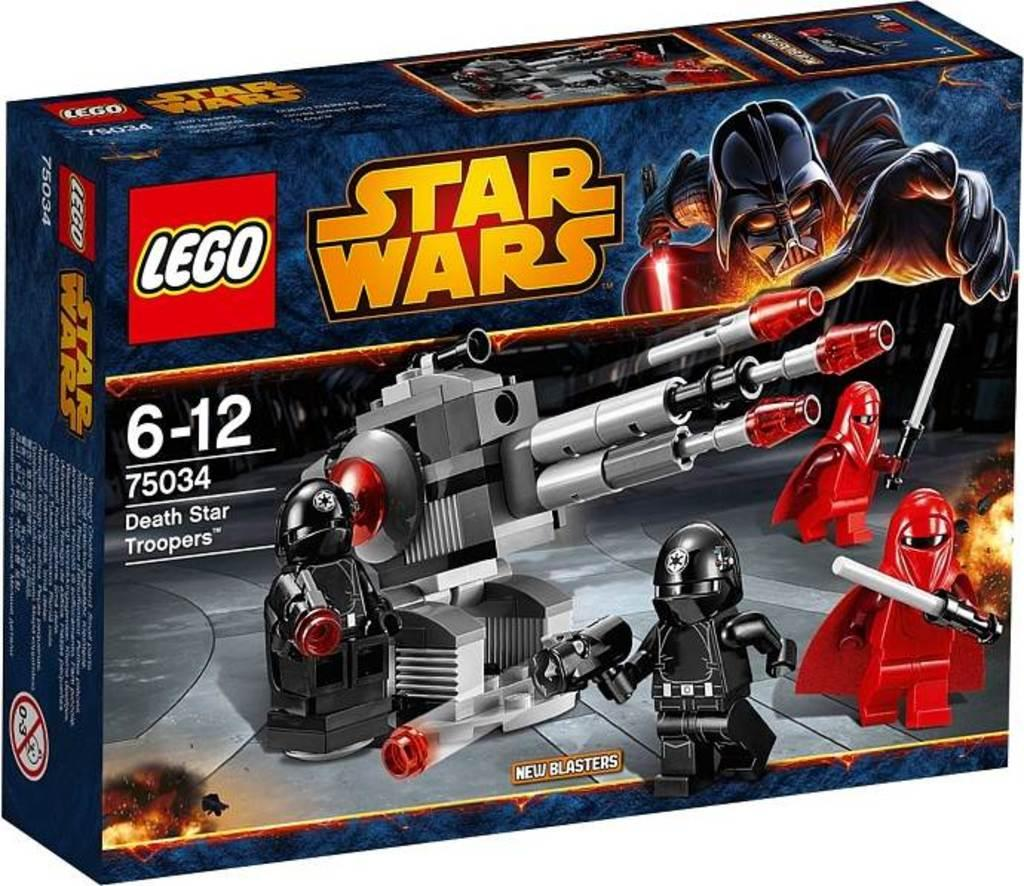<image>
Write a terse but informative summary of the picture. A Star Wars Lego Toy set says it is for ages 6-12 